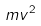Convert formula to latex. <formula><loc_0><loc_0><loc_500><loc_500>m v ^ { 2 }</formula> 